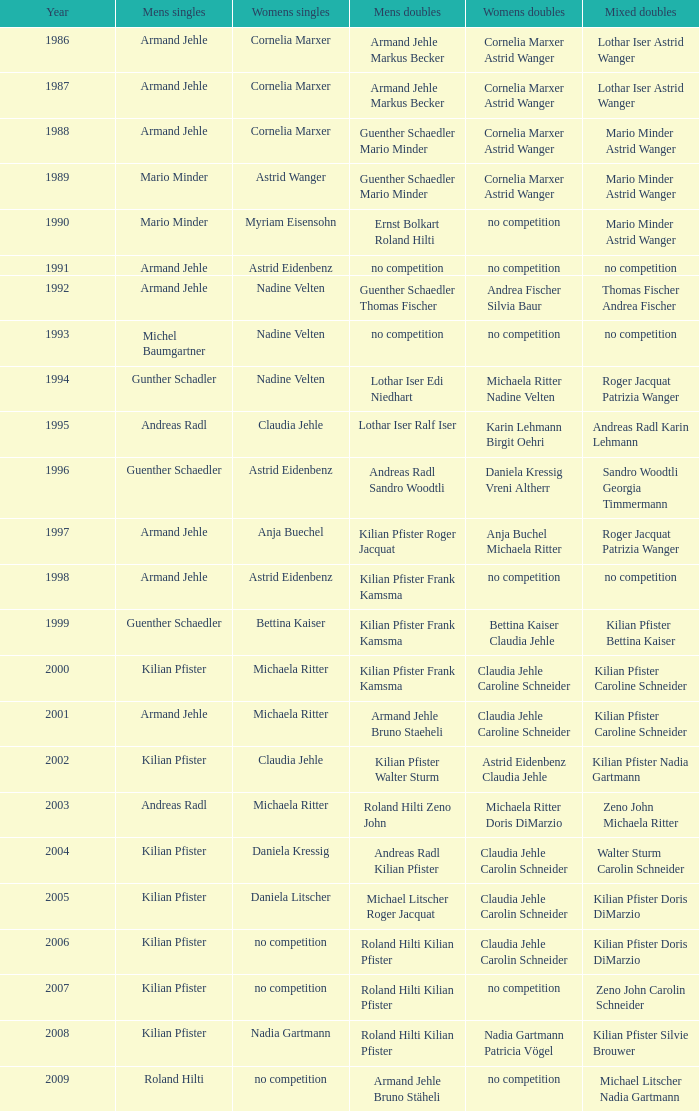In 1987 who was the mens singles Armand Jehle. 